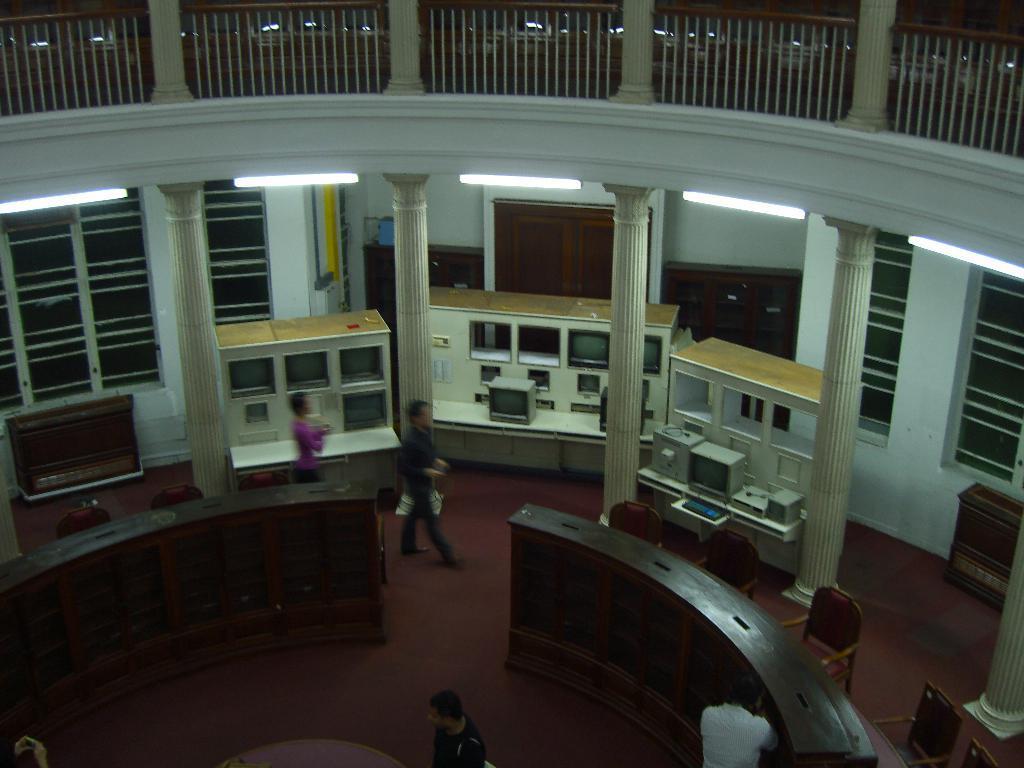How would you summarize this image in a sentence or two? This is an inside view picture of a building. In this picture we can see the railings, pillars, lights, windows, cupboard, desks. We can see the devices placed on the platforms. We can see the chairs, tables and the people. At the bottom we can see the floor. 